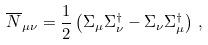Convert formula to latex. <formula><loc_0><loc_0><loc_500><loc_500>\overline { N } _ { \mu \nu } = \frac { 1 } { 2 } \left ( \Sigma _ { \mu } \Sigma _ { \nu } ^ { \dagger } - \Sigma _ { \nu } \Sigma _ { \mu } ^ { \dagger } \right ) \, ,</formula> 